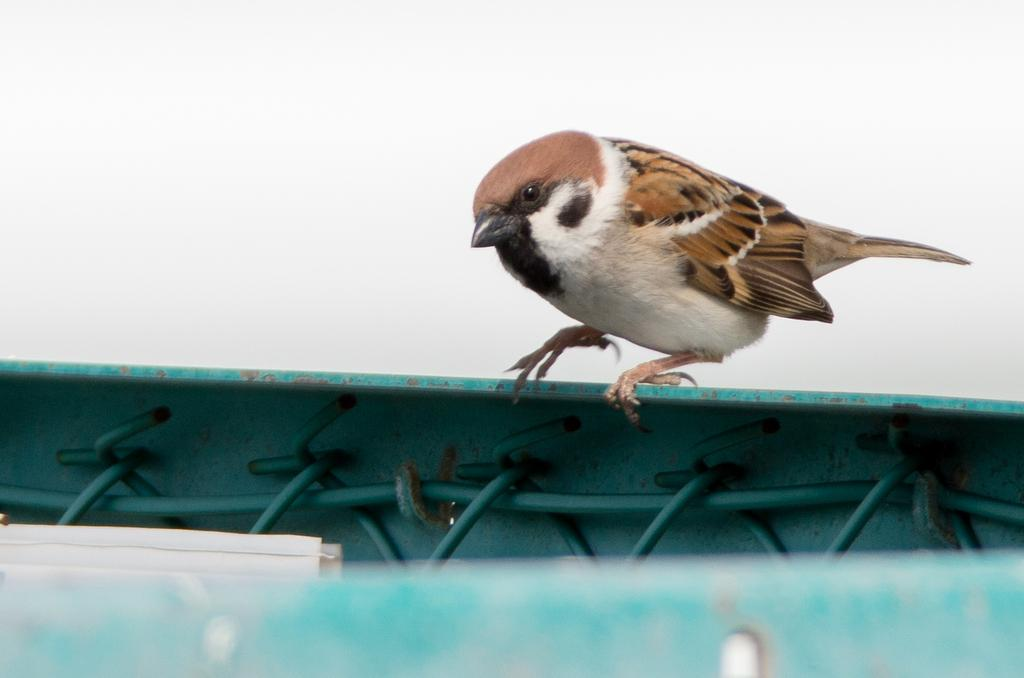What type of bird is in the image? There is a sparrow in the image. What color is the sparrow? The sparrow is brown in color. What is located at the bottom of the image? There is a fencing at the bottom of the image. What is visible at the top of the image? The sky is visible at the top of the image. Where is the toothbrush located in the image? There is no toothbrush present in the image. What type of egg can be seen in the image? There is no egg present in the image. 